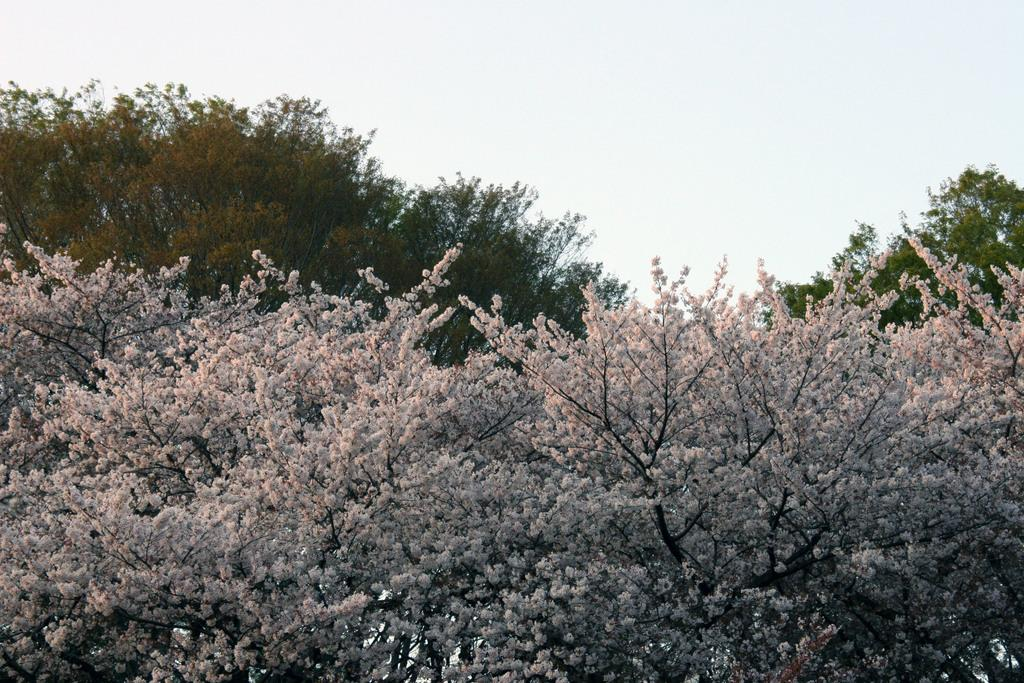What type of trees can be seen in the image? There are trees with flowers and trees with leaves in the image. What is visible at the top of the image? The sky is visible at the top of the image. What organization is responsible for the flowers on the trees in the image? There is no organization mentioned or implied in the image, as it only shows trees with flowers and leaves. 